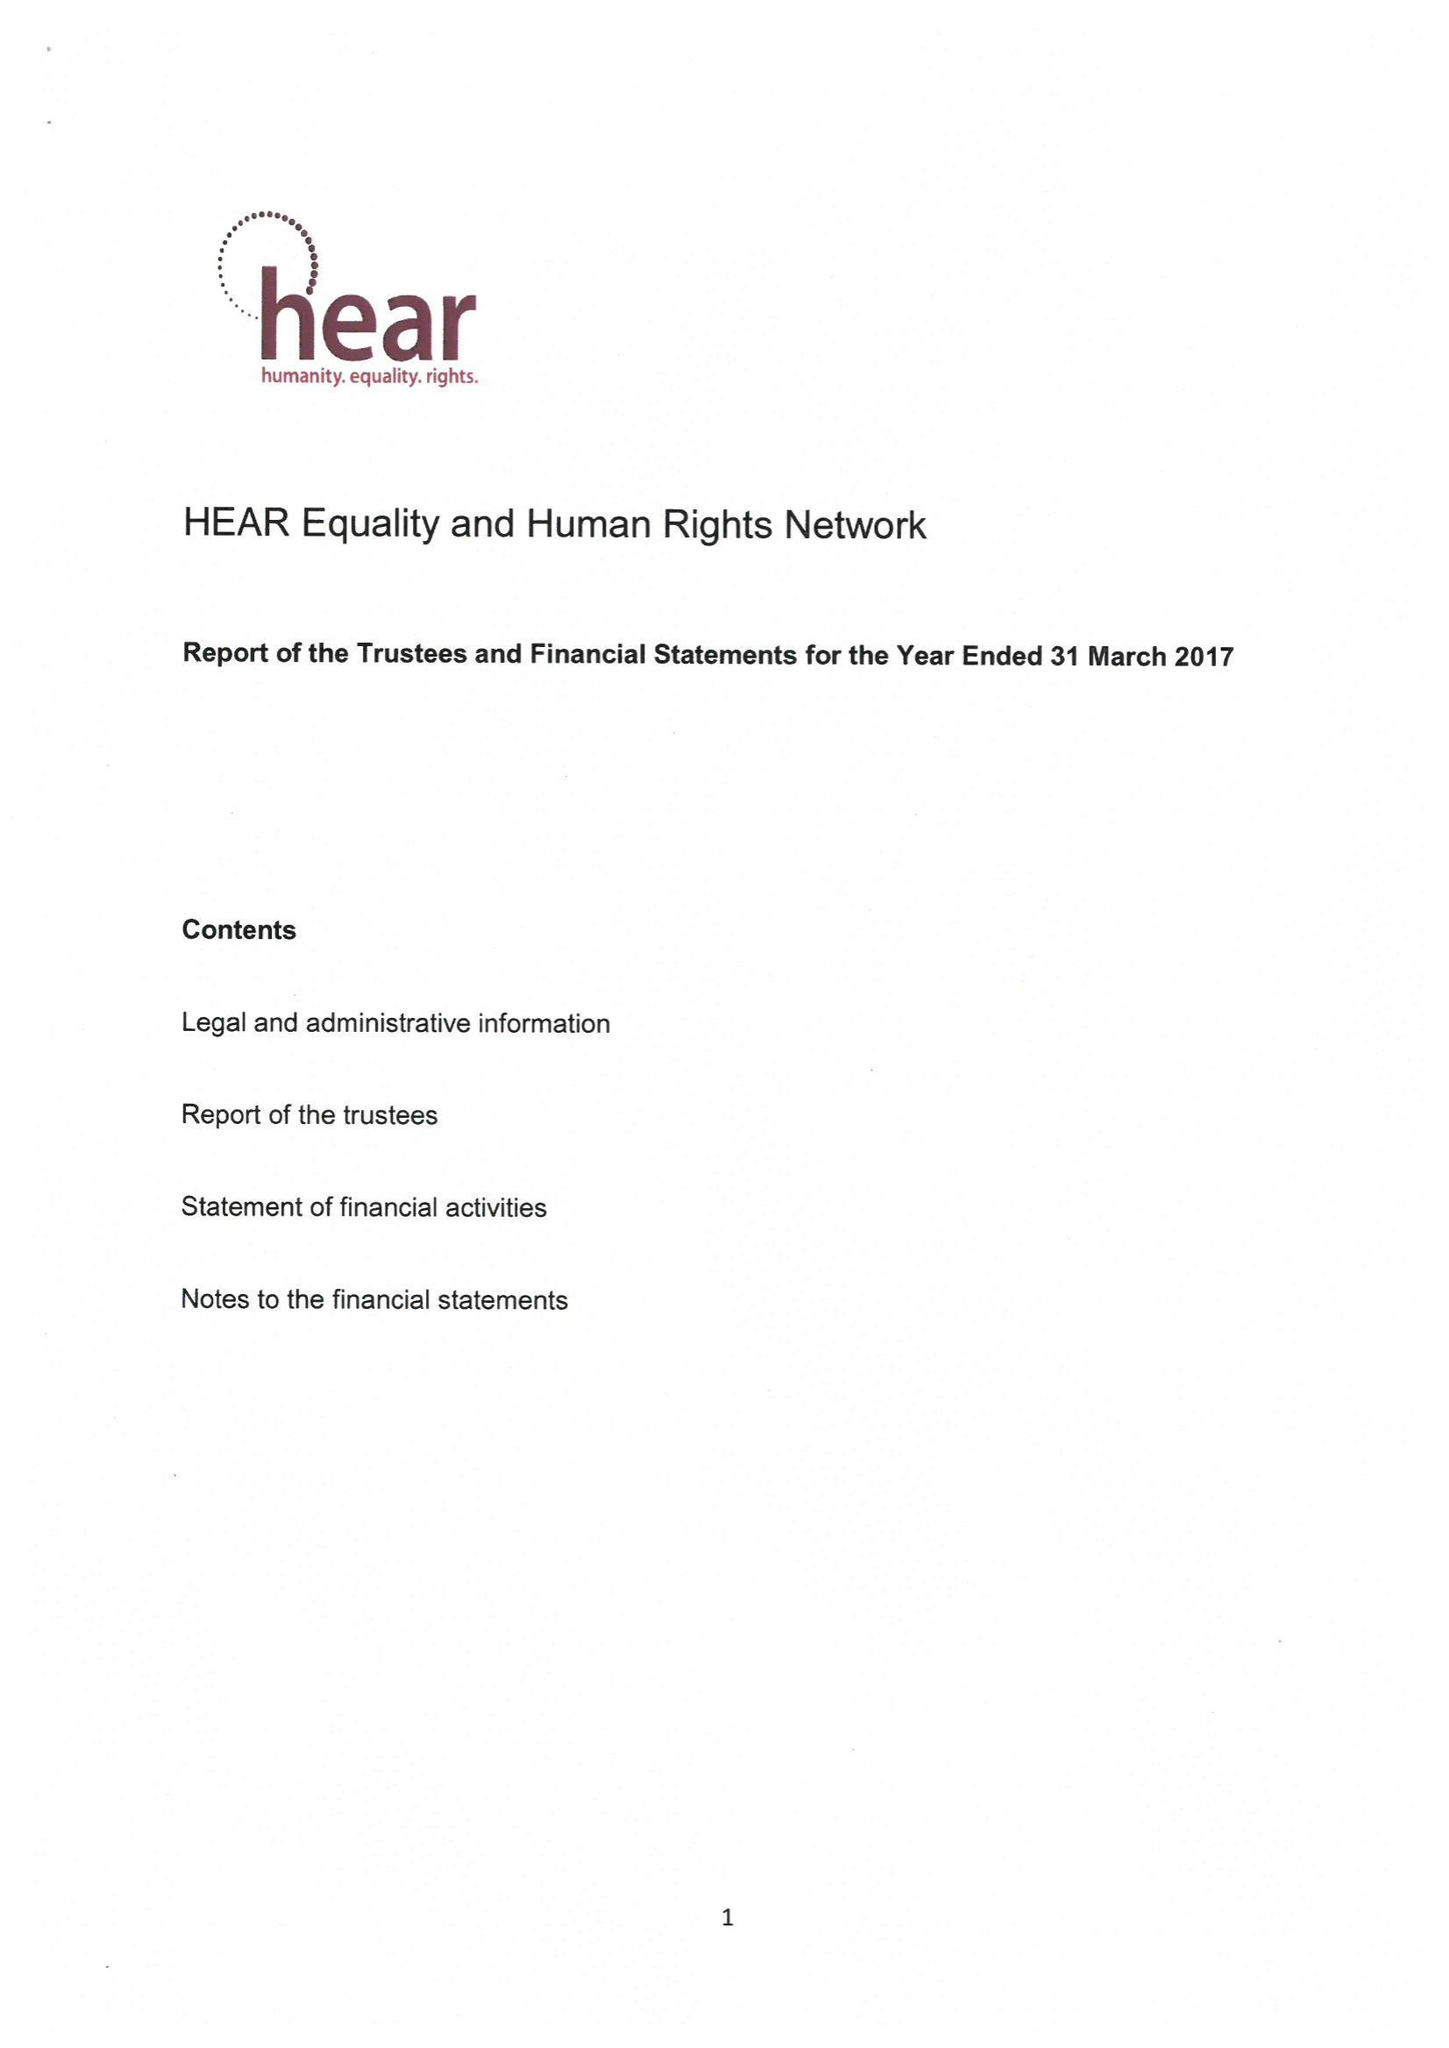What is the value for the charity_number?
Answer the question using a single word or phrase. 1168591 